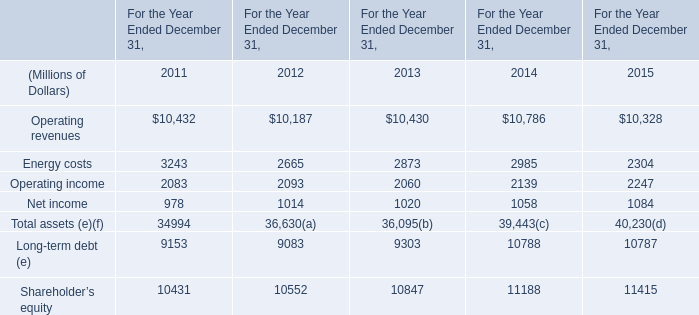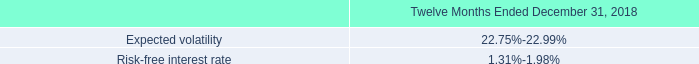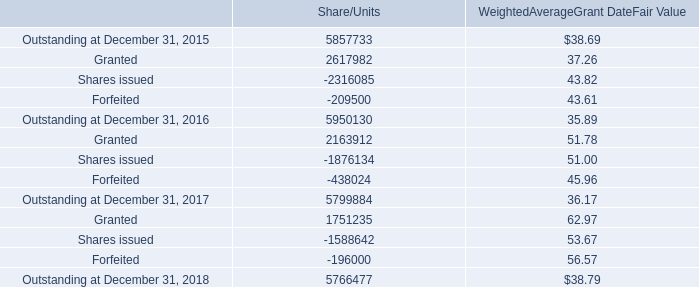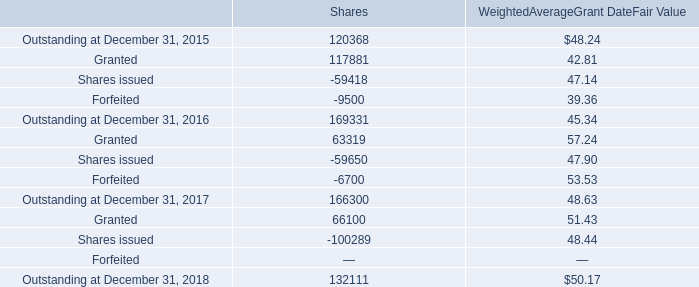What is the sum of Outstanding at December 31, 2018 of Share/Units, Energy costs of For the Year Ended December 31, 2015, and Operating revenues of For the Year Ended December 31, 2013 ? 
Computations: ((5766477.0 + 2304.0) + 10430.0)
Answer: 5779211.0. 